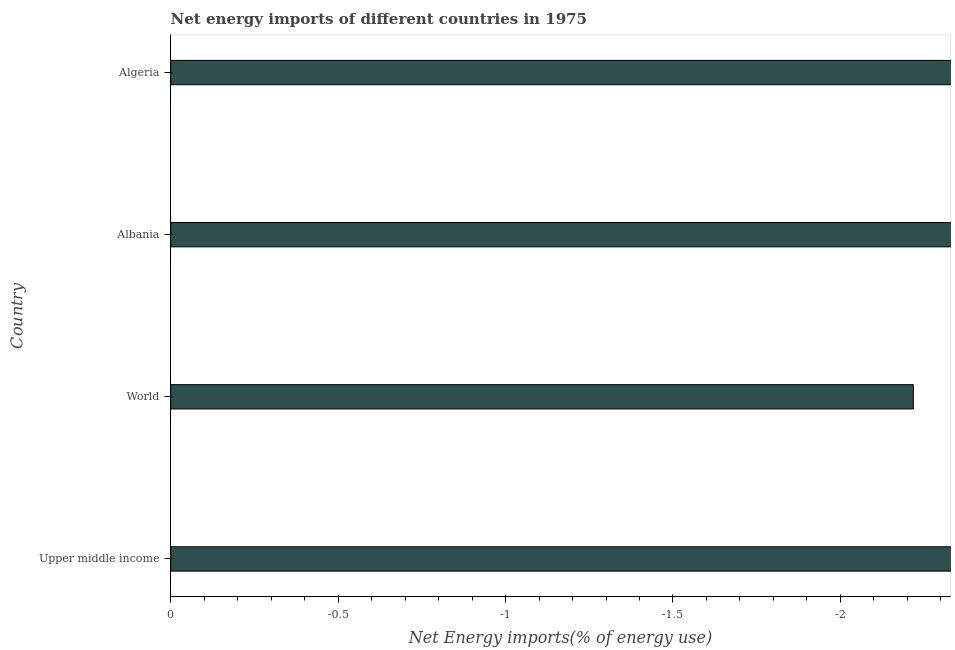Does the graph contain any zero values?
Provide a short and direct response. Yes. What is the title of the graph?
Make the answer very short. Net energy imports of different countries in 1975. What is the label or title of the X-axis?
Provide a succinct answer. Net Energy imports(% of energy use). What is the label or title of the Y-axis?
Your response must be concise. Country. Across all countries, what is the minimum energy imports?
Give a very brief answer. 0. What is the sum of the energy imports?
Offer a very short reply. 0. In how many countries, is the energy imports greater than -0.8 %?
Give a very brief answer. 0. In how many countries, is the energy imports greater than the average energy imports taken over all countries?
Provide a short and direct response. 0. How many countries are there in the graph?
Offer a very short reply. 4. What is the difference between two consecutive major ticks on the X-axis?
Provide a short and direct response. 0.5. Are the values on the major ticks of X-axis written in scientific E-notation?
Give a very brief answer. No. What is the Net Energy imports(% of energy use) in Upper middle income?
Your answer should be compact. 0. What is the Net Energy imports(% of energy use) in World?
Offer a terse response. 0. What is the Net Energy imports(% of energy use) in Algeria?
Provide a short and direct response. 0. 